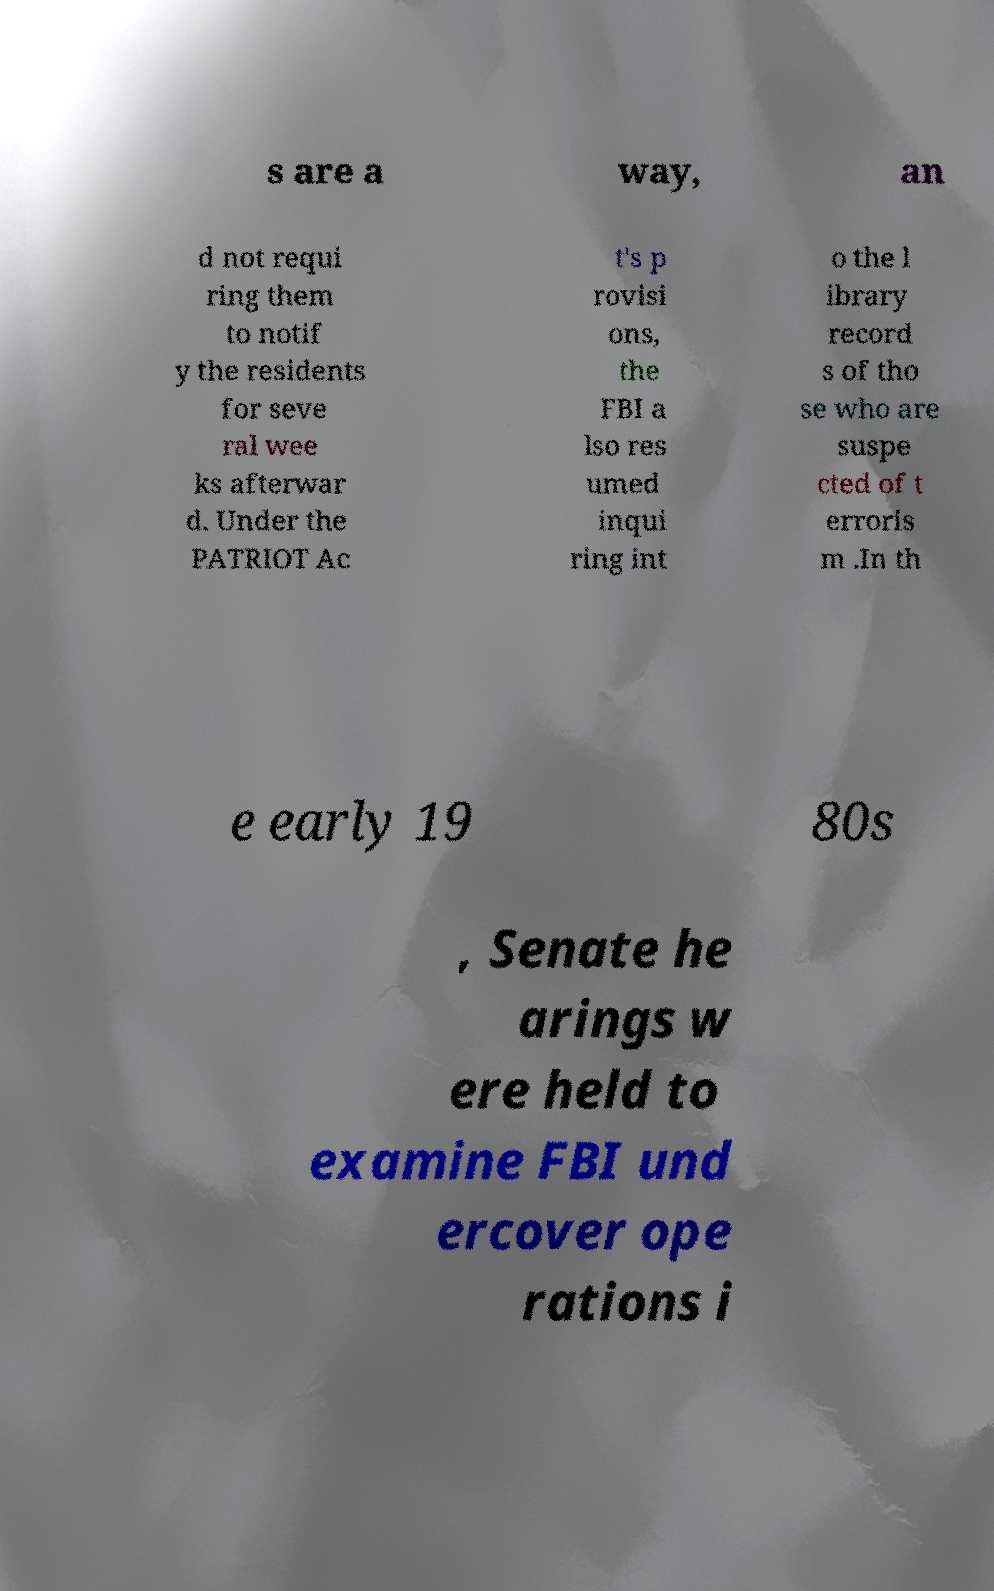There's text embedded in this image that I need extracted. Can you transcribe it verbatim? s are a way, an d not requi ring them to notif y the residents for seve ral wee ks afterwar d. Under the PATRIOT Ac t's p rovisi ons, the FBI a lso res umed inqui ring int o the l ibrary record s of tho se who are suspe cted of t erroris m .In th e early 19 80s , Senate he arings w ere held to examine FBI und ercover ope rations i 